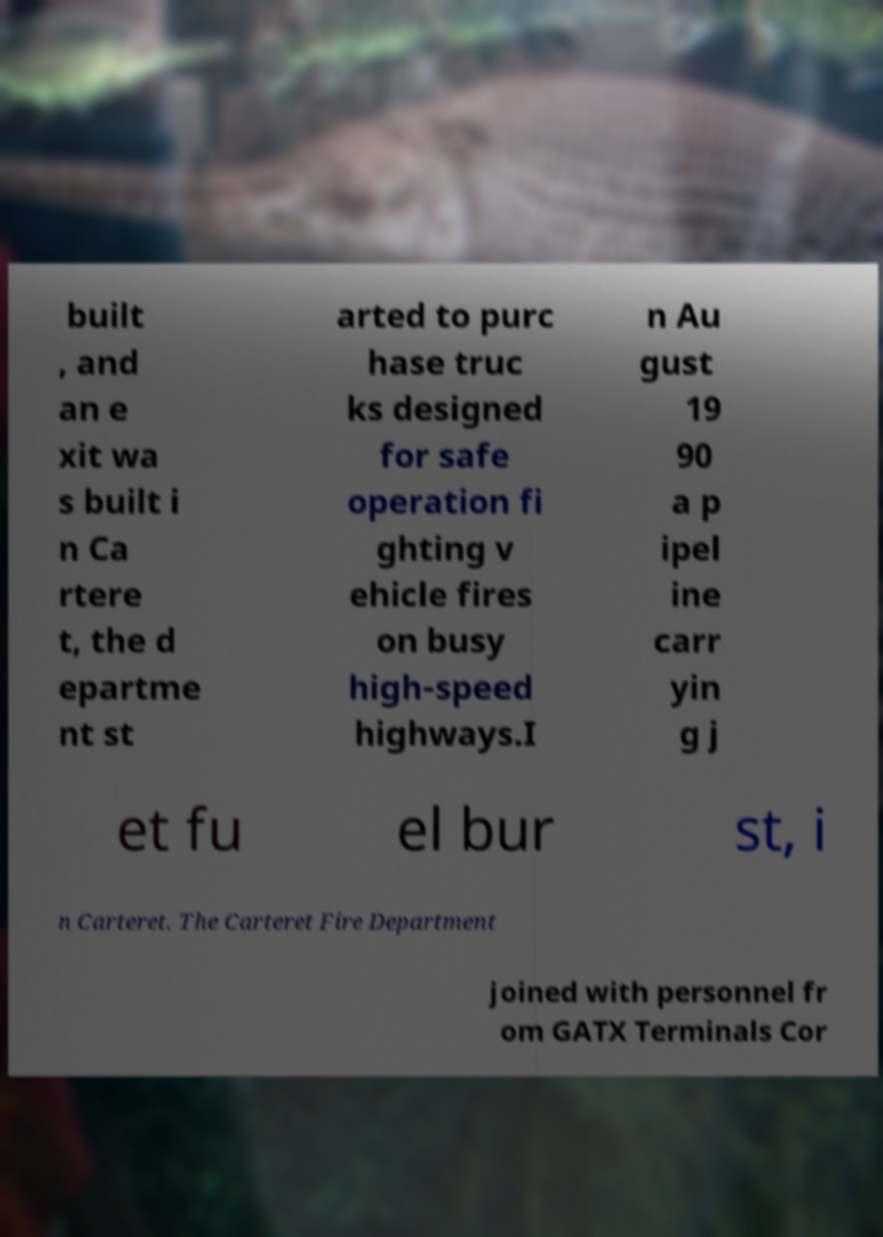Could you assist in decoding the text presented in this image and type it out clearly? built , and an e xit wa s built i n Ca rtere t, the d epartme nt st arted to purc hase truc ks designed for safe operation fi ghting v ehicle fires on busy high-speed highways.I n Au gust 19 90 a p ipel ine carr yin g j et fu el bur st, i n Carteret. The Carteret Fire Department joined with personnel fr om GATX Terminals Cor 